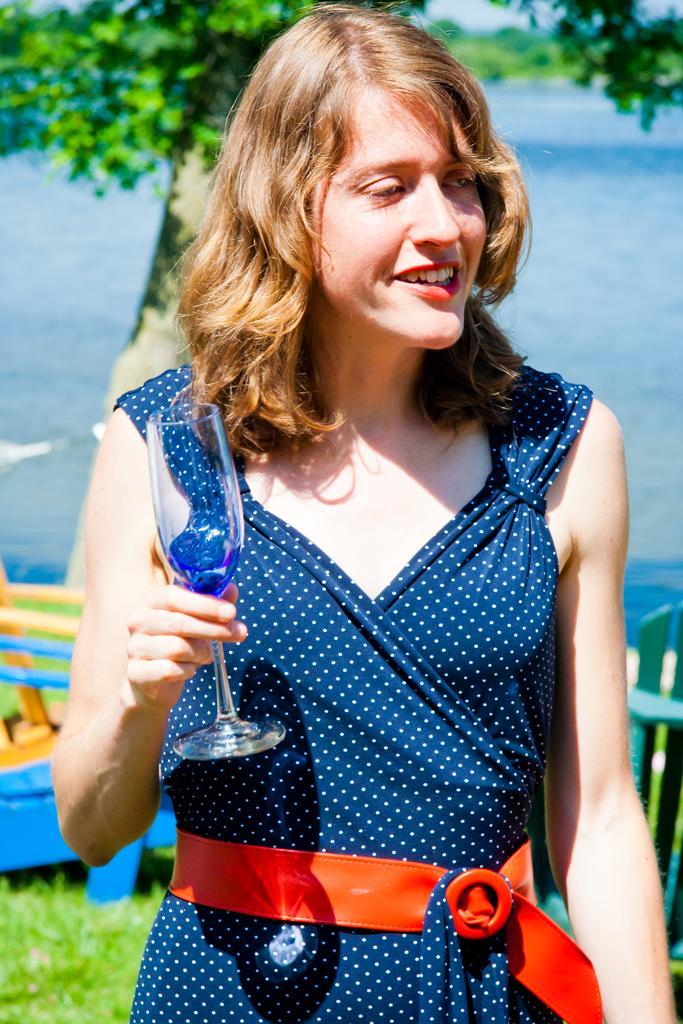Please provide a concise description of this image. This image is taken outdoors. In the background there are a few trees and plants on the ground. At the bottom of the image there is a ground with grass on it. On the left side of the image there is a resting chair on the ground. In the middle of the image of a woman is standing and she is holding a wine glass in her hand and she is with a smiling face. 